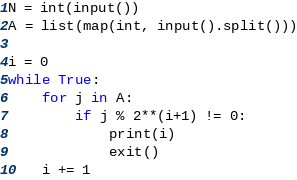Convert code to text. <code><loc_0><loc_0><loc_500><loc_500><_Python_>N = int(input())
A = list(map(int, input().split()))

i = 0
while True:
    for j in A:
        if j % 2**(i+1) != 0:
            print(i)
            exit()
    i += 1
</code> 